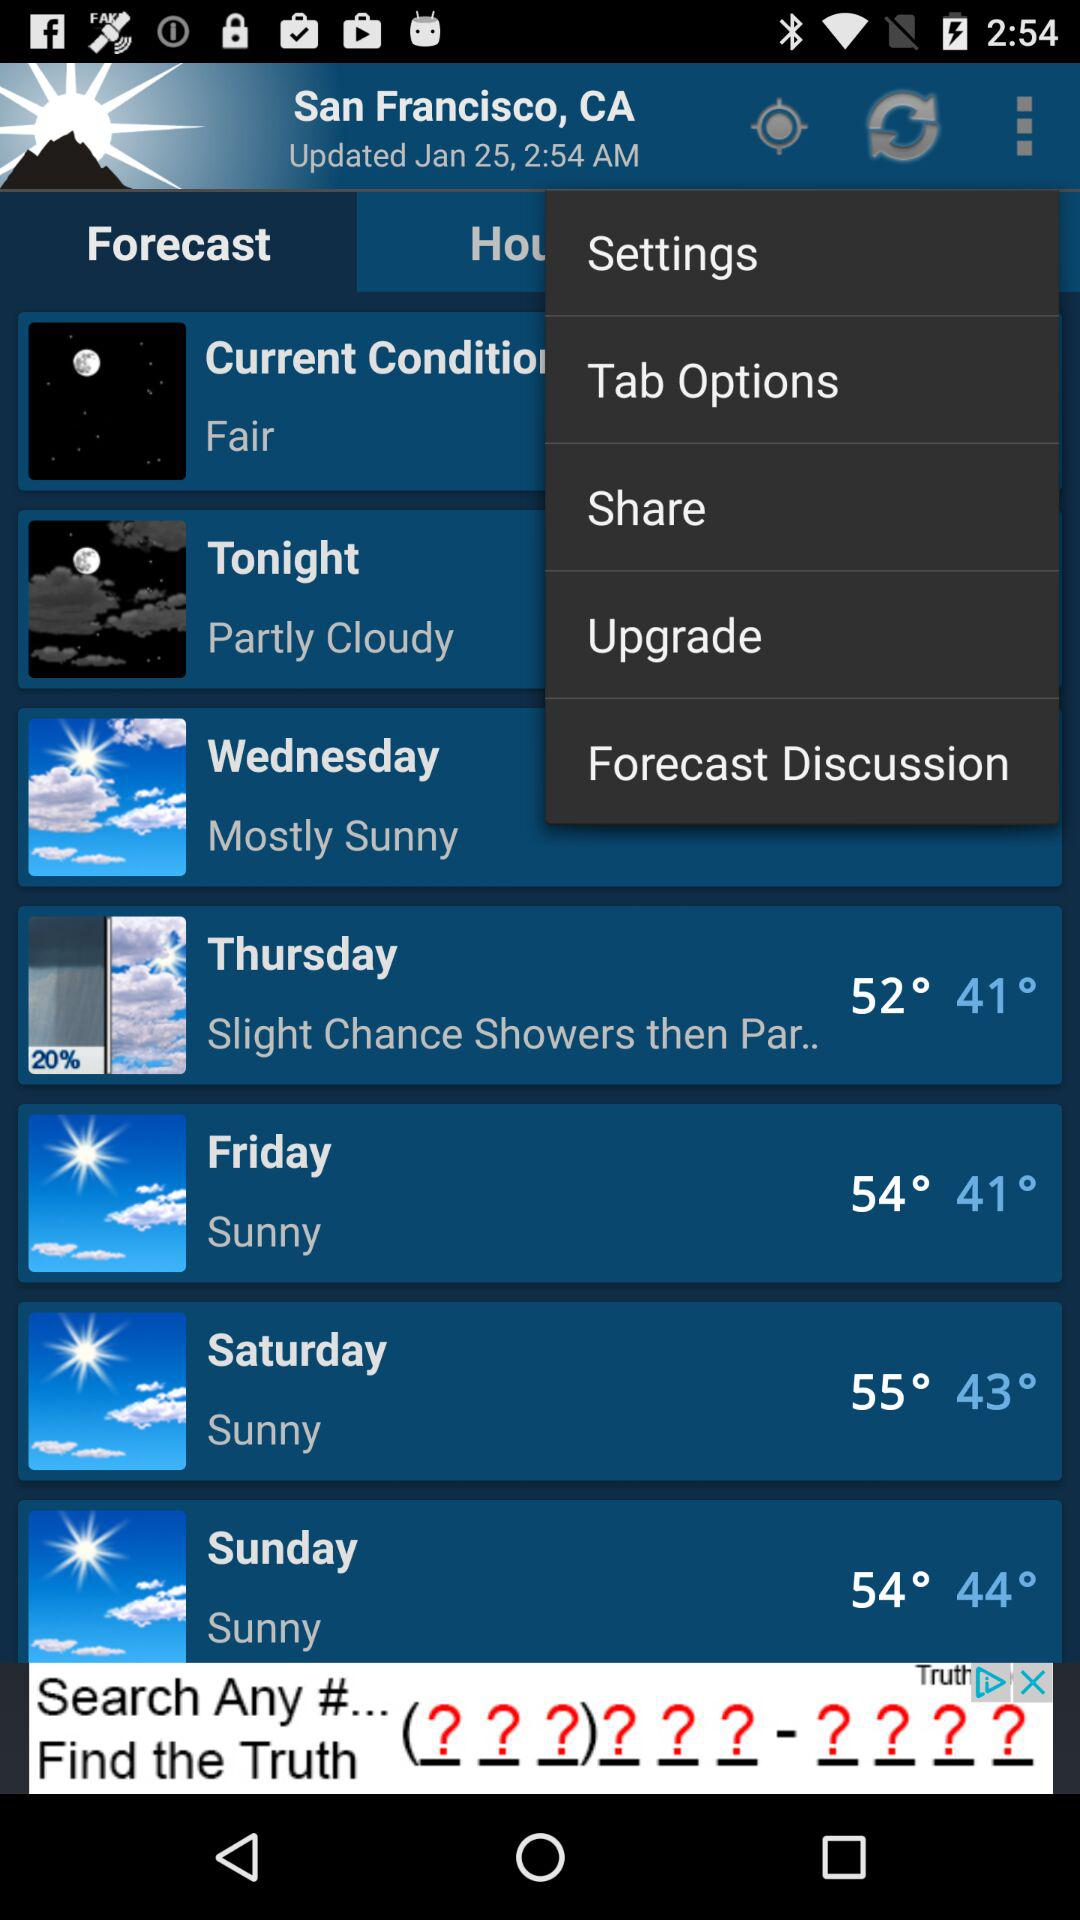What is the location? The location is San Francisco, CA. 